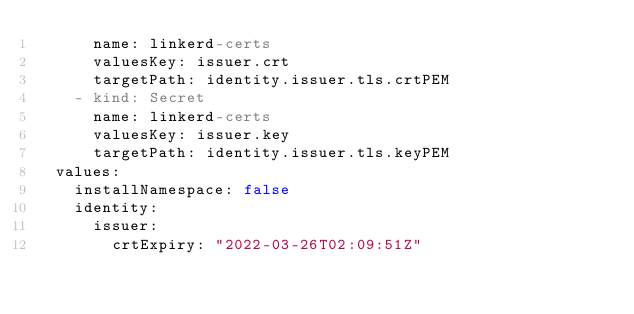<code> <loc_0><loc_0><loc_500><loc_500><_YAML_>      name: linkerd-certs
      valuesKey: issuer.crt
      targetPath: identity.issuer.tls.crtPEM
    - kind: Secret
      name: linkerd-certs
      valuesKey: issuer.key
      targetPath: identity.issuer.tls.keyPEM
  values:
    installNamespace: false
    identity:
      issuer:
        crtExpiry: "2022-03-26T02:09:51Z"</code> 